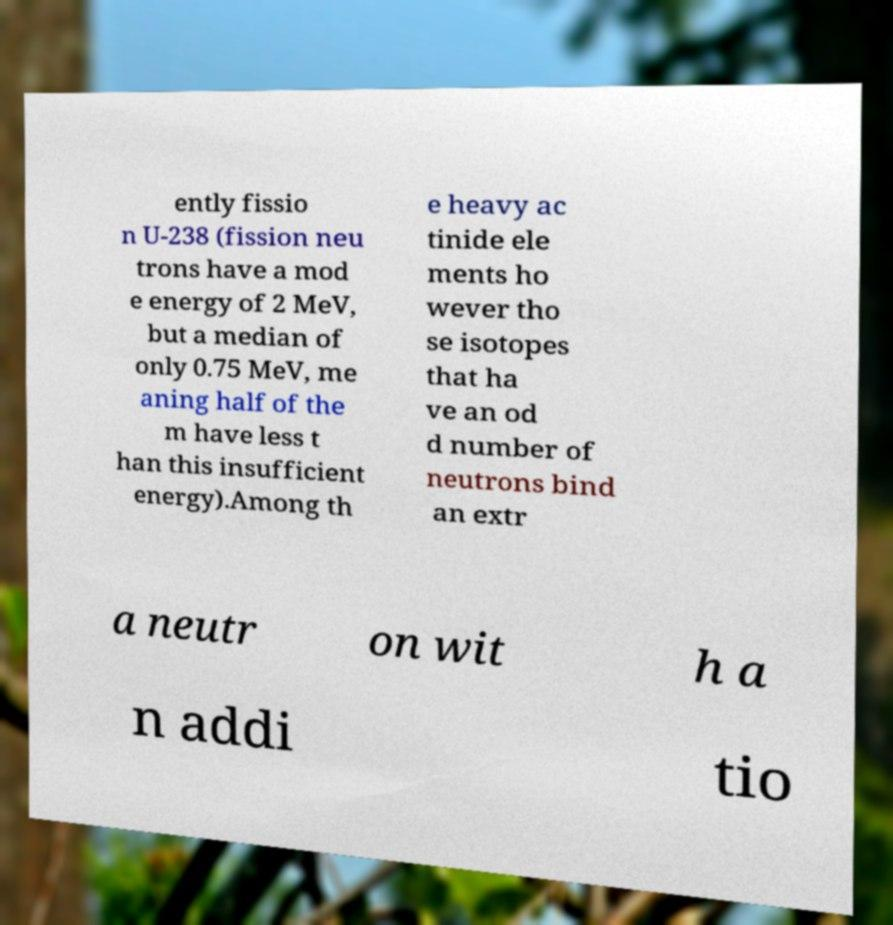There's text embedded in this image that I need extracted. Can you transcribe it verbatim? ently fissio n U-238 (fission neu trons have a mod e energy of 2 MeV, but a median of only 0.75 MeV, me aning half of the m have less t han this insufficient energy).Among th e heavy ac tinide ele ments ho wever tho se isotopes that ha ve an od d number of neutrons bind an extr a neutr on wit h a n addi tio 